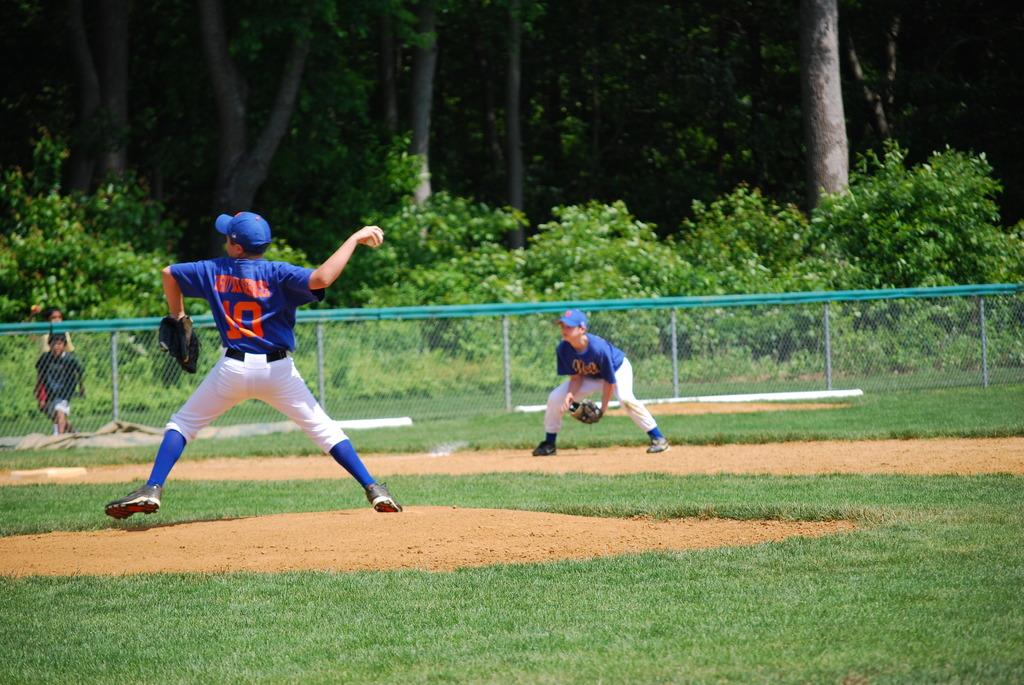<image>
Relay a brief, clear account of the picture shown. A couple of players from the Mets play a game of basketball. 